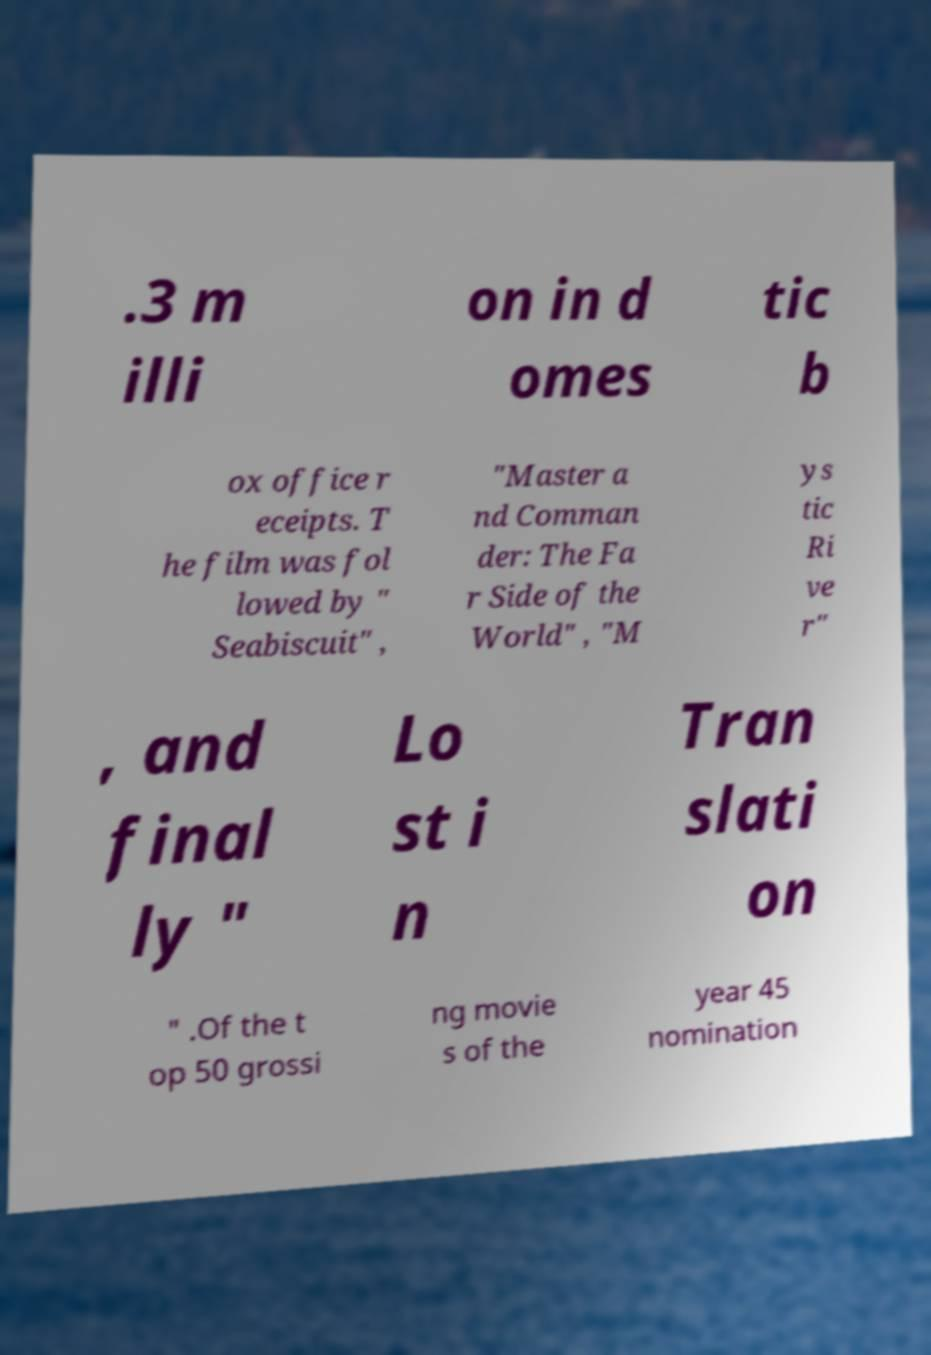Could you extract and type out the text from this image? .3 m illi on in d omes tic b ox office r eceipts. T he film was fol lowed by " Seabiscuit" , "Master a nd Comman der: The Fa r Side of the World" , "M ys tic Ri ve r" , and final ly " Lo st i n Tran slati on " .Of the t op 50 grossi ng movie s of the year 45 nomination 